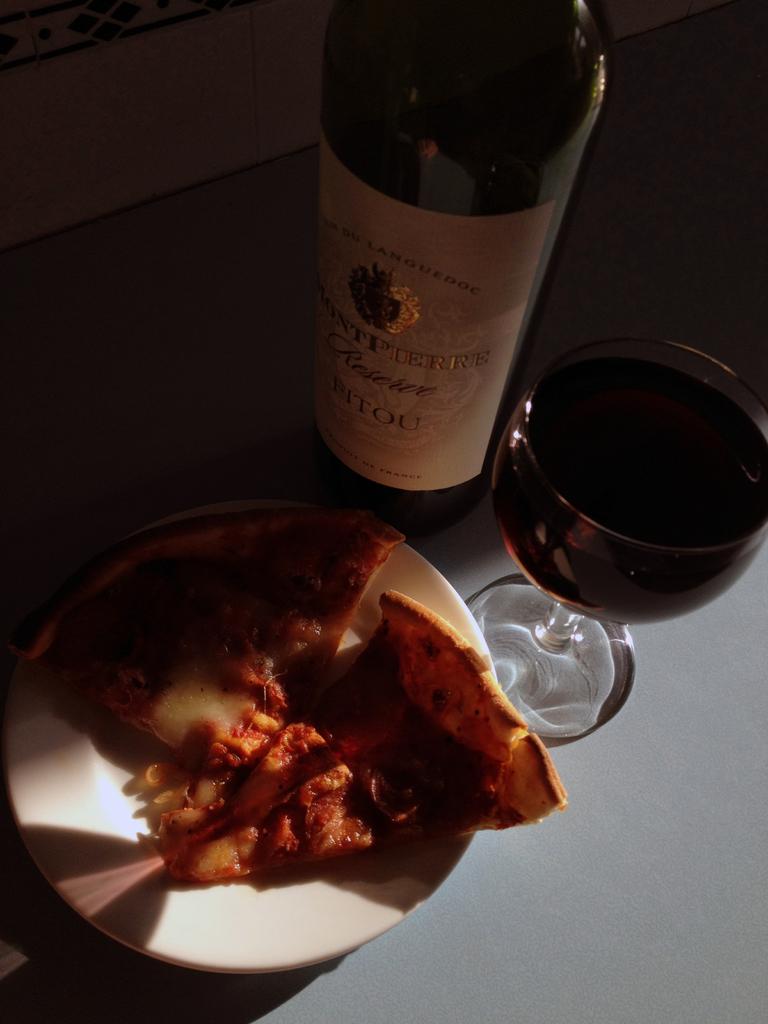What type of wine is this?
Provide a short and direct response. Fitou. 